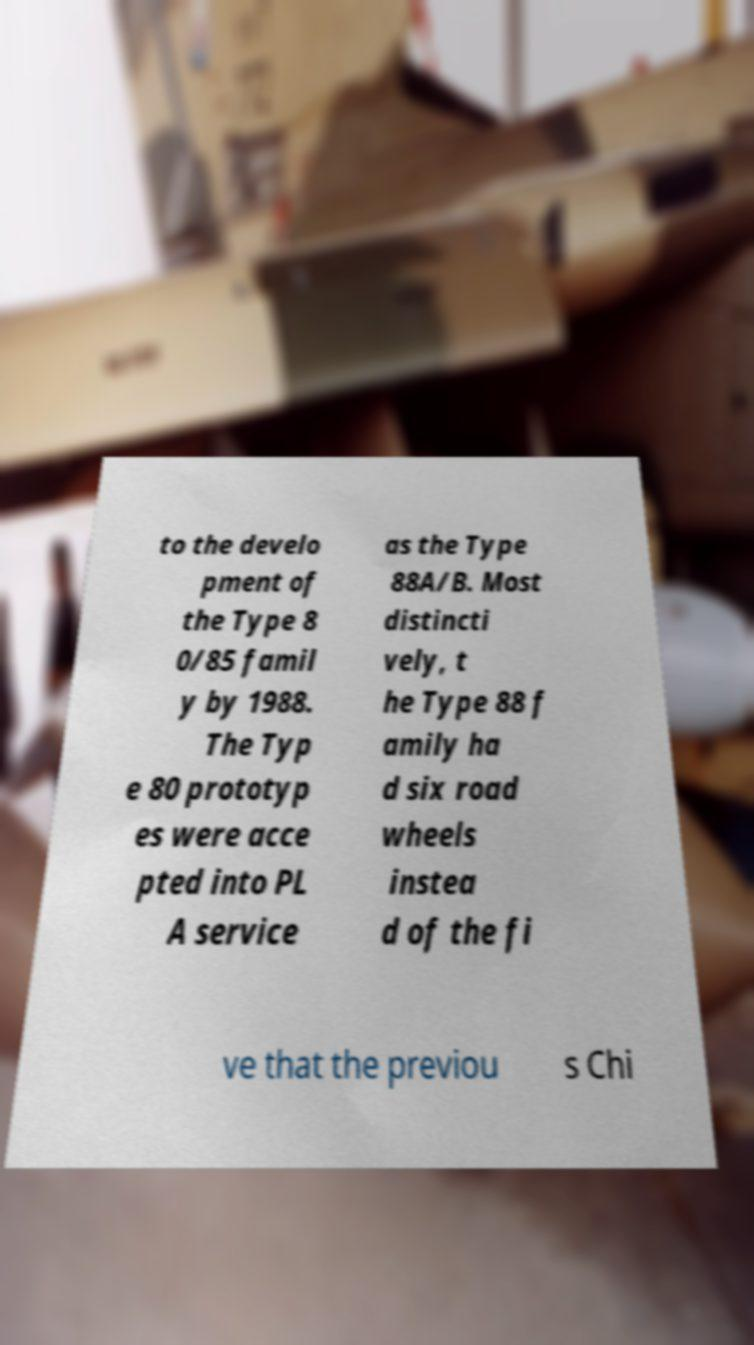There's text embedded in this image that I need extracted. Can you transcribe it verbatim? to the develo pment of the Type 8 0/85 famil y by 1988. The Typ e 80 prototyp es were acce pted into PL A service as the Type 88A/B. Most distincti vely, t he Type 88 f amily ha d six road wheels instea d of the fi ve that the previou s Chi 